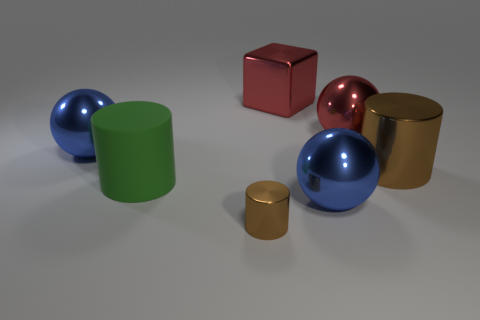Subtract all metal cylinders. How many cylinders are left? 1 Subtract all red spheres. How many spheres are left? 2 Subtract all blocks. How many objects are left? 6 Subtract 2 cylinders. How many cylinders are left? 1 Add 2 red shiny cubes. How many objects exist? 9 Subtract 0 gray spheres. How many objects are left? 7 Subtract all blue balls. Subtract all purple cylinders. How many balls are left? 1 Subtract all brown balls. How many yellow cylinders are left? 0 Subtract all big green cylinders. Subtract all brown objects. How many objects are left? 4 Add 5 brown things. How many brown things are left? 7 